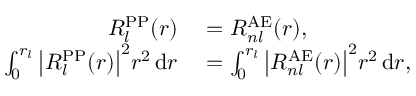Convert formula to latex. <formula><loc_0><loc_0><loc_500><loc_500>\begin{array} { r l } { R _ { l } ^ { P P } ( r ) } & = R _ { n l } ^ { A E } ( r ) , } \\ { \int _ { 0 } ^ { r _ { l } } { \left | } R _ { l } ^ { P P } ( r ) { \right | } ^ { 2 } r ^ { 2 } \, d r } & = \int _ { 0 } ^ { r _ { l } } { \left | } R _ { n l } ^ { A E } ( r ) { \right | } ^ { 2 } r ^ { 2 } \, d r , } \end{array}</formula> 